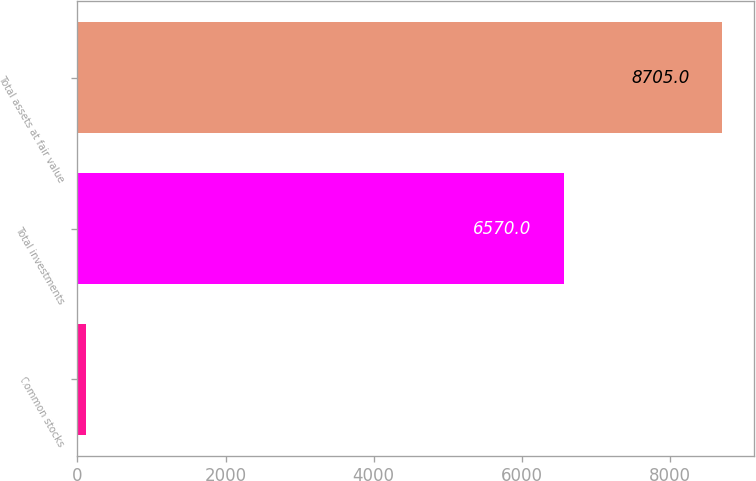Convert chart to OTSL. <chart><loc_0><loc_0><loc_500><loc_500><bar_chart><fcel>Common stocks<fcel>Total investments<fcel>Total assets at fair value<nl><fcel>123<fcel>6570<fcel>8705<nl></chart> 